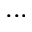Convert formula to latex. <formula><loc_0><loc_0><loc_500><loc_500>\dots</formula> 